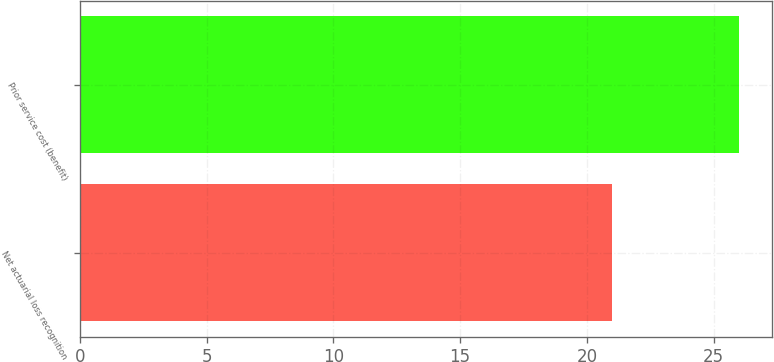Convert chart. <chart><loc_0><loc_0><loc_500><loc_500><bar_chart><fcel>Net actuarial loss recognition<fcel>Prior service cost (benefit)<nl><fcel>21<fcel>26<nl></chart> 